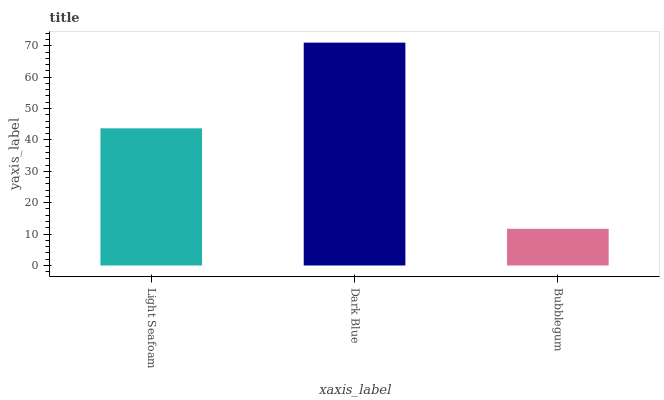Is Dark Blue the minimum?
Answer yes or no. No. Is Bubblegum the maximum?
Answer yes or no. No. Is Dark Blue greater than Bubblegum?
Answer yes or no. Yes. Is Bubblegum less than Dark Blue?
Answer yes or no. Yes. Is Bubblegum greater than Dark Blue?
Answer yes or no. No. Is Dark Blue less than Bubblegum?
Answer yes or no. No. Is Light Seafoam the high median?
Answer yes or no. Yes. Is Light Seafoam the low median?
Answer yes or no. Yes. Is Dark Blue the high median?
Answer yes or no. No. Is Bubblegum the low median?
Answer yes or no. No. 